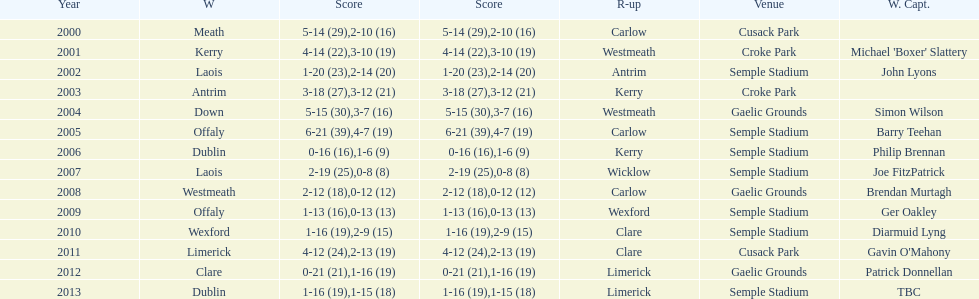Who was the first winning captain? Michael 'Boxer' Slattery. 